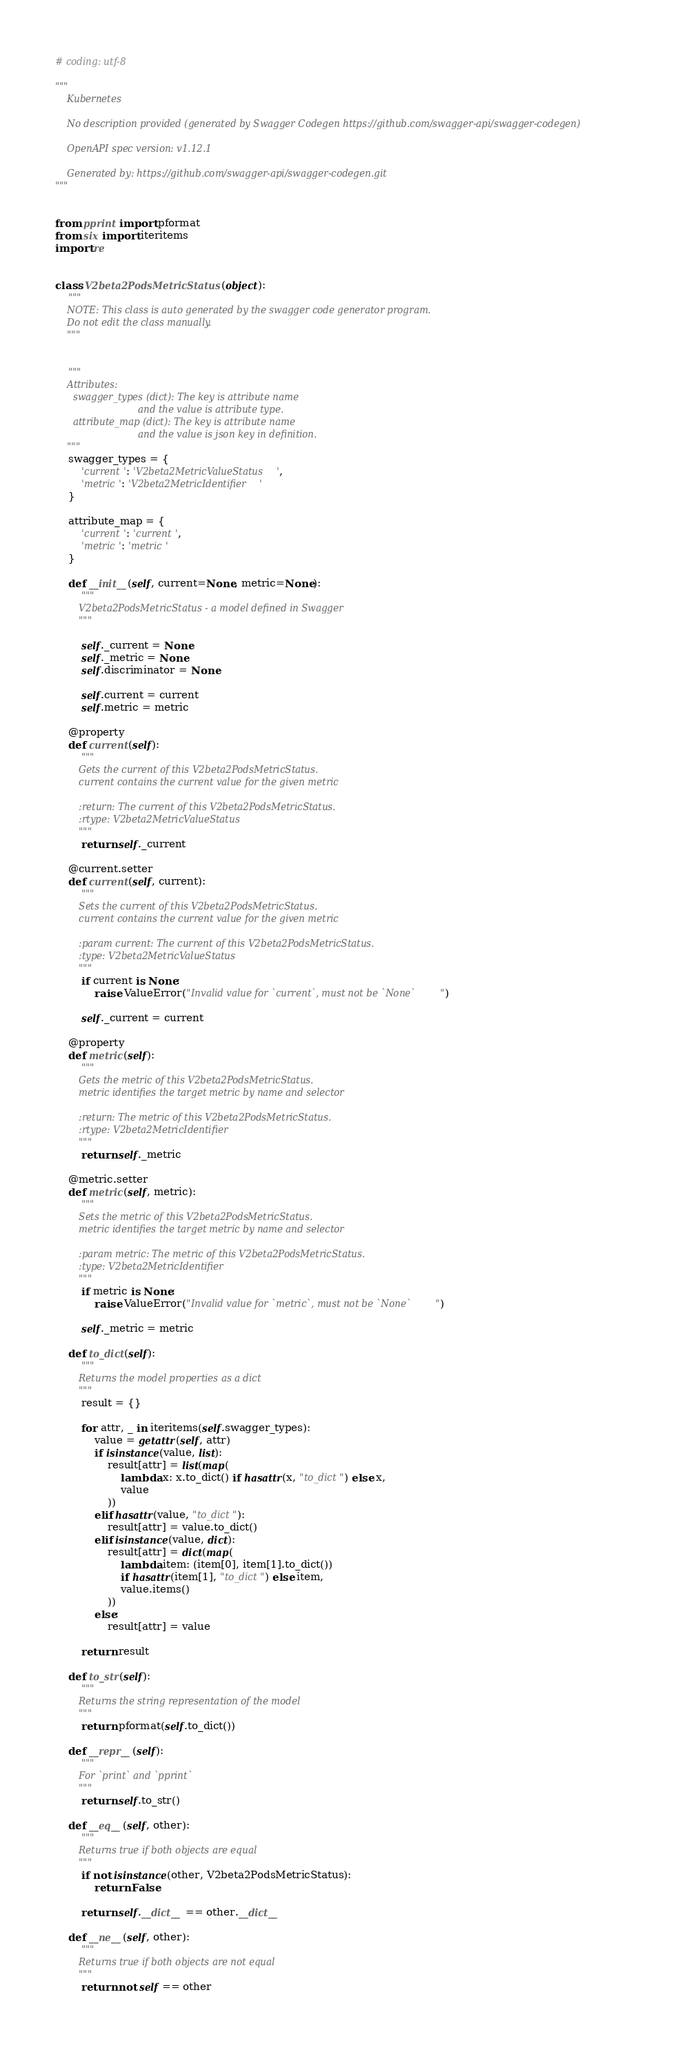<code> <loc_0><loc_0><loc_500><loc_500><_Python_># coding: utf-8

"""
    Kubernetes

    No description provided (generated by Swagger Codegen https://github.com/swagger-api/swagger-codegen)

    OpenAPI spec version: v1.12.1
    
    Generated by: https://github.com/swagger-api/swagger-codegen.git
"""


from pprint import pformat
from six import iteritems
import re


class V2beta2PodsMetricStatus(object):
    """
    NOTE: This class is auto generated by the swagger code generator program.
    Do not edit the class manually.
    """


    """
    Attributes:
      swagger_types (dict): The key is attribute name
                            and the value is attribute type.
      attribute_map (dict): The key is attribute name
                            and the value is json key in definition.
    """
    swagger_types = {
        'current': 'V2beta2MetricValueStatus',
        'metric': 'V2beta2MetricIdentifier'
    }

    attribute_map = {
        'current': 'current',
        'metric': 'metric'
    }

    def __init__(self, current=None, metric=None):
        """
        V2beta2PodsMetricStatus - a model defined in Swagger
        """

        self._current = None
        self._metric = None
        self.discriminator = None

        self.current = current
        self.metric = metric

    @property
    def current(self):
        """
        Gets the current of this V2beta2PodsMetricStatus.
        current contains the current value for the given metric

        :return: The current of this V2beta2PodsMetricStatus.
        :rtype: V2beta2MetricValueStatus
        """
        return self._current

    @current.setter
    def current(self, current):
        """
        Sets the current of this V2beta2PodsMetricStatus.
        current contains the current value for the given metric

        :param current: The current of this V2beta2PodsMetricStatus.
        :type: V2beta2MetricValueStatus
        """
        if current is None:
            raise ValueError("Invalid value for `current`, must not be `None`")

        self._current = current

    @property
    def metric(self):
        """
        Gets the metric of this V2beta2PodsMetricStatus.
        metric identifies the target metric by name and selector

        :return: The metric of this V2beta2PodsMetricStatus.
        :rtype: V2beta2MetricIdentifier
        """
        return self._metric

    @metric.setter
    def metric(self, metric):
        """
        Sets the metric of this V2beta2PodsMetricStatus.
        metric identifies the target metric by name and selector

        :param metric: The metric of this V2beta2PodsMetricStatus.
        :type: V2beta2MetricIdentifier
        """
        if metric is None:
            raise ValueError("Invalid value for `metric`, must not be `None`")

        self._metric = metric

    def to_dict(self):
        """
        Returns the model properties as a dict
        """
        result = {}

        for attr, _ in iteritems(self.swagger_types):
            value = getattr(self, attr)
            if isinstance(value, list):
                result[attr] = list(map(
                    lambda x: x.to_dict() if hasattr(x, "to_dict") else x,
                    value
                ))
            elif hasattr(value, "to_dict"):
                result[attr] = value.to_dict()
            elif isinstance(value, dict):
                result[attr] = dict(map(
                    lambda item: (item[0], item[1].to_dict())
                    if hasattr(item[1], "to_dict") else item,
                    value.items()
                ))
            else:
                result[attr] = value

        return result

    def to_str(self):
        """
        Returns the string representation of the model
        """
        return pformat(self.to_dict())

    def __repr__(self):
        """
        For `print` and `pprint`
        """
        return self.to_str()

    def __eq__(self, other):
        """
        Returns true if both objects are equal
        """
        if not isinstance(other, V2beta2PodsMetricStatus):
            return False

        return self.__dict__ == other.__dict__

    def __ne__(self, other):
        """
        Returns true if both objects are not equal
        """
        return not self == other
</code> 